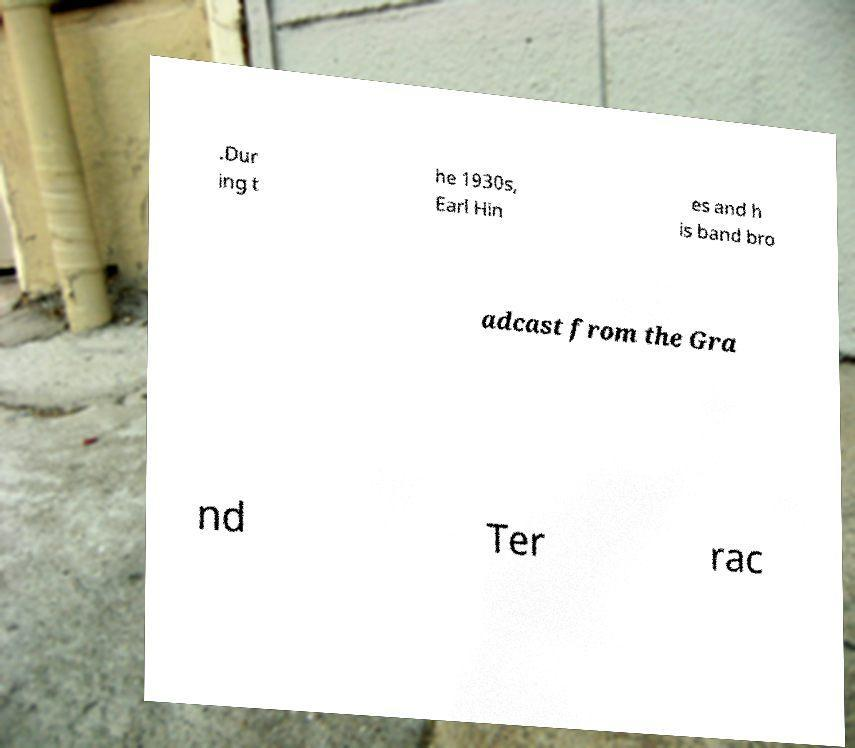For documentation purposes, I need the text within this image transcribed. Could you provide that? .Dur ing t he 1930s, Earl Hin es and h is band bro adcast from the Gra nd Ter rac 